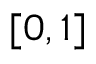Convert formula to latex. <formula><loc_0><loc_0><loc_500><loc_500>[ 0 , 1 ]</formula> 